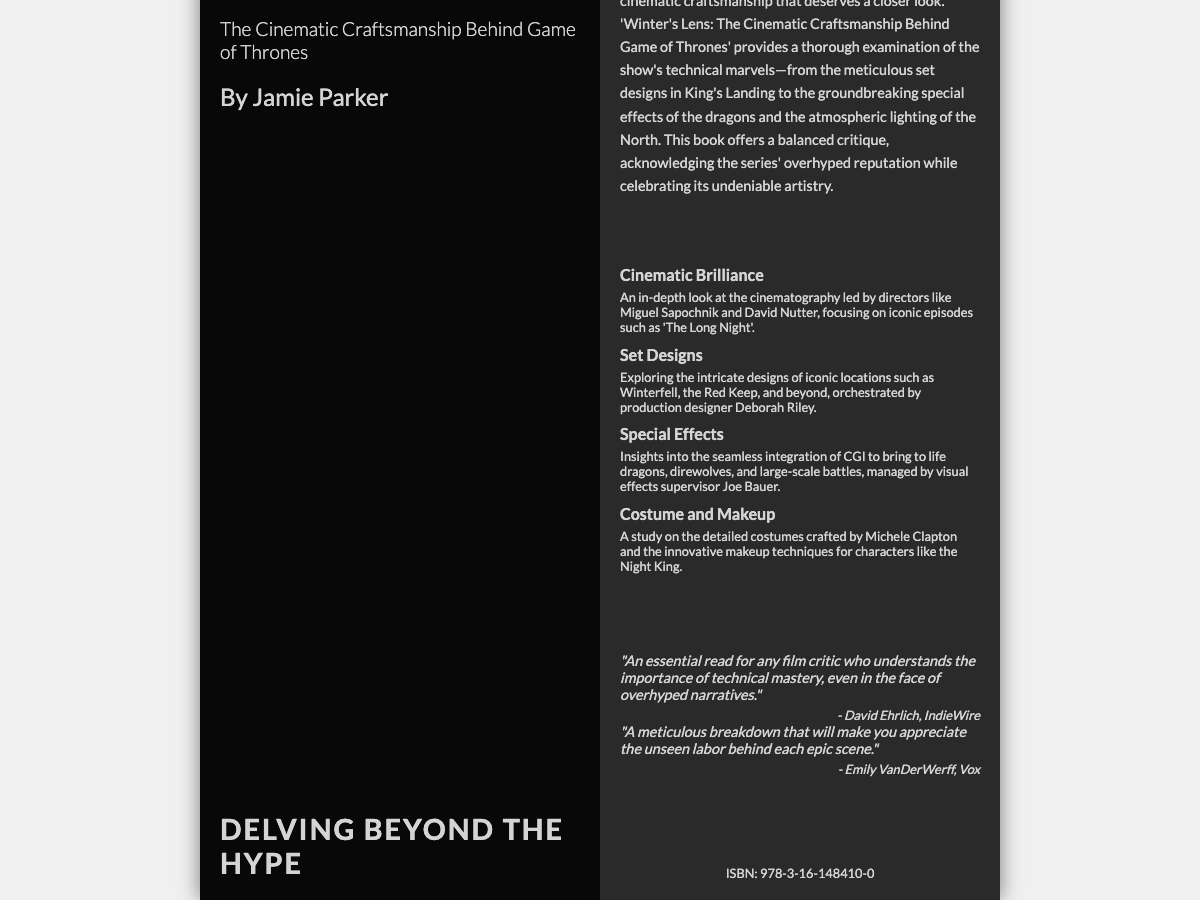What is the title of the book? The title of the book is presented prominently on the front cover as "Winter's Lens."
Answer: Winter's Lens Who is the author of the book? The author is listed below the title on the front cover, reading "By Jamie Parker."
Answer: Jamie Parker What is the subtitle of the book? The subtitle is found right under the title on the front cover, emphasizing the main theme.
Answer: The Cinematic Craftsmanship Behind Game of Thrones Which notable director's cinematography is discussed in the book? The book highlights cinematic brilliance led by directors, specifically mentioning Miguel Sapochnik and David Nutter.
Answer: Miguel Sapochnik and David Nutter What location's set design is explored in the book? The back cover discusses intricate designs of iconic locations such as Winterfell, which is one of the key settings in the series.
Answer: Winterfell What special character makeup techniques are mentioned? The book examines the detailed makeup techniques for characters like the Night King, which are part of the show's artistic effort.
Answer: Night King What is a key highlight related to special effects? The back cover outlines insights related to CGI integration for bringing dragons to life, indicating a focus on special effects.
Answer: Dragons What ISBN number is provided? The barcode section at the bottom of the back cover provides the ISBN number of the book.
Answer: 978-3-16-148410-0 